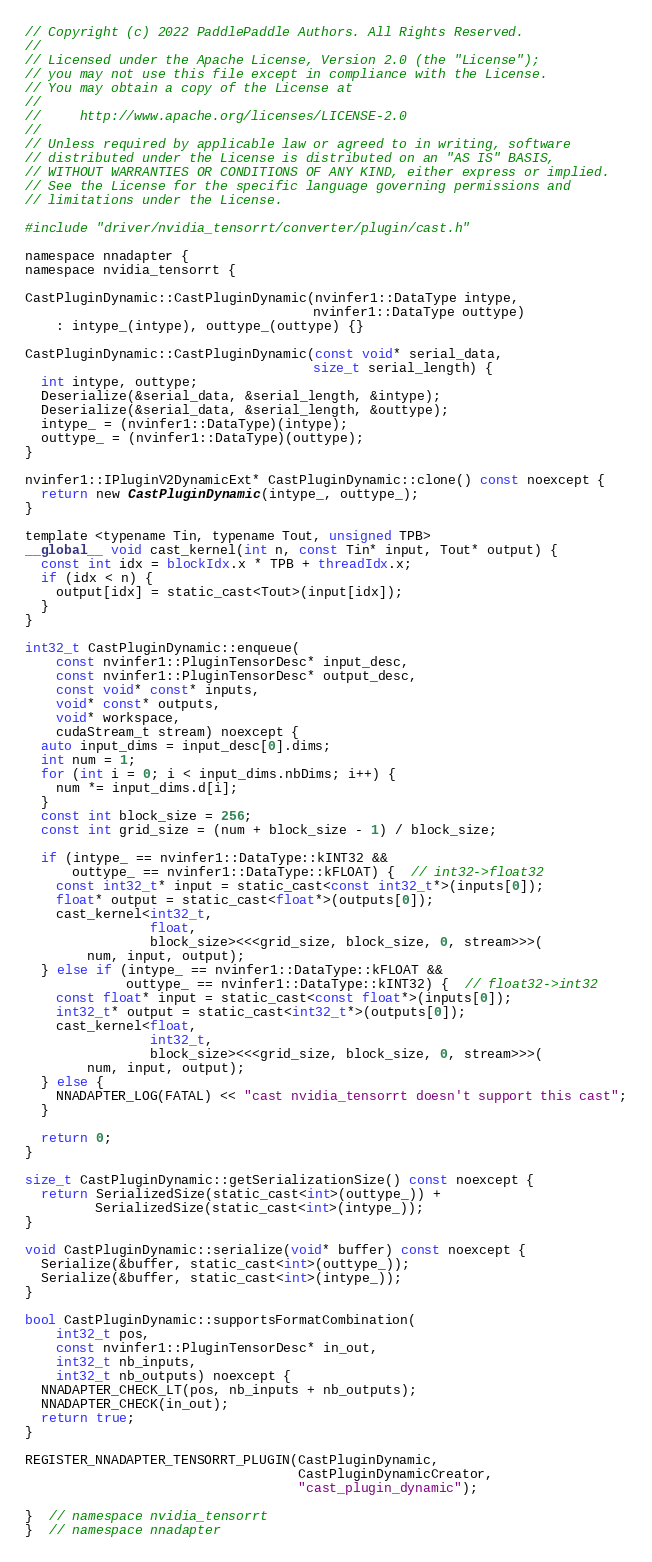Convert code to text. <code><loc_0><loc_0><loc_500><loc_500><_Cuda_>// Copyright (c) 2022 PaddlePaddle Authors. All Rights Reserved.
//
// Licensed under the Apache License, Version 2.0 (the "License");
// you may not use this file except in compliance with the License.
// You may obtain a copy of the License at
//
//     http://www.apache.org/licenses/LICENSE-2.0
//
// Unless required by applicable law or agreed to in writing, software
// distributed under the License is distributed on an "AS IS" BASIS,
// WITHOUT WARRANTIES OR CONDITIONS OF ANY KIND, either express or implied.
// See the License for the specific language governing permissions and
// limitations under the License.

#include "driver/nvidia_tensorrt/converter/plugin/cast.h"

namespace nnadapter {
namespace nvidia_tensorrt {

CastPluginDynamic::CastPluginDynamic(nvinfer1::DataType intype,
                                     nvinfer1::DataType outtype)
    : intype_(intype), outtype_(outtype) {}

CastPluginDynamic::CastPluginDynamic(const void* serial_data,
                                     size_t serial_length) {
  int intype, outtype;
  Deserialize(&serial_data, &serial_length, &intype);
  Deserialize(&serial_data, &serial_length, &outtype);
  intype_ = (nvinfer1::DataType)(intype);
  outtype_ = (nvinfer1::DataType)(outtype);
}

nvinfer1::IPluginV2DynamicExt* CastPluginDynamic::clone() const noexcept {
  return new CastPluginDynamic(intype_, outtype_);
}

template <typename Tin, typename Tout, unsigned TPB>
__global__ void cast_kernel(int n, const Tin* input, Tout* output) {
  const int idx = blockIdx.x * TPB + threadIdx.x;
  if (idx < n) {
    output[idx] = static_cast<Tout>(input[idx]);
  }
}

int32_t CastPluginDynamic::enqueue(
    const nvinfer1::PluginTensorDesc* input_desc,
    const nvinfer1::PluginTensorDesc* output_desc,
    const void* const* inputs,
    void* const* outputs,
    void* workspace,
    cudaStream_t stream) noexcept {
  auto input_dims = input_desc[0].dims;
  int num = 1;
  for (int i = 0; i < input_dims.nbDims; i++) {
    num *= input_dims.d[i];
  }
  const int block_size = 256;
  const int grid_size = (num + block_size - 1) / block_size;

  if (intype_ == nvinfer1::DataType::kINT32 &&
      outtype_ == nvinfer1::DataType::kFLOAT) {  // int32->float32
    const int32_t* input = static_cast<const int32_t*>(inputs[0]);
    float* output = static_cast<float*>(outputs[0]);
    cast_kernel<int32_t,
                float,
                block_size><<<grid_size, block_size, 0, stream>>>(
        num, input, output);
  } else if (intype_ == nvinfer1::DataType::kFLOAT &&
             outtype_ == nvinfer1::DataType::kINT32) {  // float32->int32
    const float* input = static_cast<const float*>(inputs[0]);
    int32_t* output = static_cast<int32_t*>(outputs[0]);
    cast_kernel<float,
                int32_t,
                block_size><<<grid_size, block_size, 0, stream>>>(
        num, input, output);
  } else {
    NNADAPTER_LOG(FATAL) << "cast nvidia_tensorrt doesn't support this cast";
  }

  return 0;
}

size_t CastPluginDynamic::getSerializationSize() const noexcept {
  return SerializedSize(static_cast<int>(outtype_)) +
         SerializedSize(static_cast<int>(intype_));
}

void CastPluginDynamic::serialize(void* buffer) const noexcept {
  Serialize(&buffer, static_cast<int>(outtype_));
  Serialize(&buffer, static_cast<int>(intype_));
}

bool CastPluginDynamic::supportsFormatCombination(
    int32_t pos,
    const nvinfer1::PluginTensorDesc* in_out,
    int32_t nb_inputs,
    int32_t nb_outputs) noexcept {
  NNADAPTER_CHECK_LT(pos, nb_inputs + nb_outputs);
  NNADAPTER_CHECK(in_out);
  return true;
}

REGISTER_NNADAPTER_TENSORRT_PLUGIN(CastPluginDynamic,
                                   CastPluginDynamicCreator,
                                   "cast_plugin_dynamic");

}  // namespace nvidia_tensorrt
}  // namespace nnadapter
</code> 